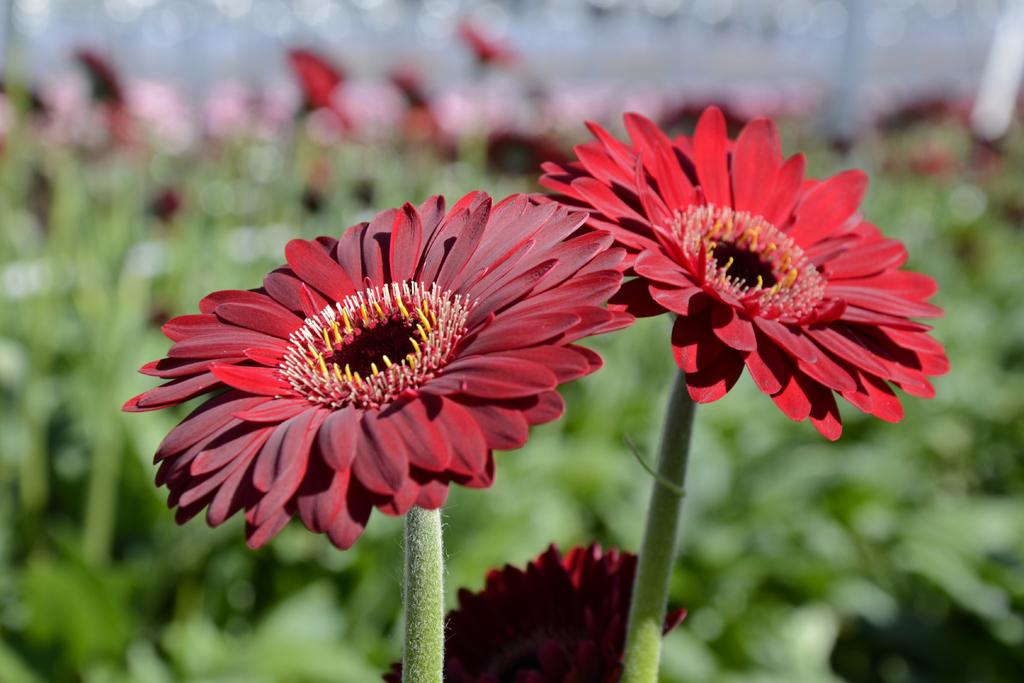What is the main subject in the middle of the image? There are flowers in the middle of the image. Can you describe the background of the image? The background of the image is blurred. What type of cushion can be seen in the image? There is no cushion present in the image. What time of day is it in the image? The time of day cannot be determined from the image, as there are no clues to suggest morning or any other time. 